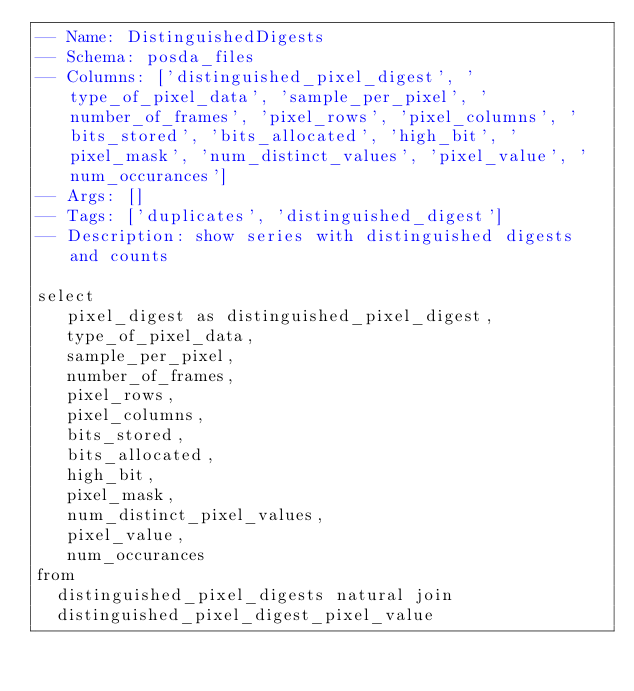<code> <loc_0><loc_0><loc_500><loc_500><_SQL_>-- Name: DistinguishedDigests
-- Schema: posda_files
-- Columns: ['distinguished_pixel_digest', 'type_of_pixel_data', 'sample_per_pixel', 'number_of_frames', 'pixel_rows', 'pixel_columns', 'bits_stored', 'bits_allocated', 'high_bit', 'pixel_mask', 'num_distinct_values', 'pixel_value', 'num_occurances']
-- Args: []
-- Tags: ['duplicates', 'distinguished_digest']
-- Description: show series with distinguished digests and counts

select
   pixel_digest as distinguished_pixel_digest,
   type_of_pixel_data,
   sample_per_pixel,
   number_of_frames,
   pixel_rows,
   pixel_columns,
   bits_stored,
   bits_allocated,
   high_bit,
   pixel_mask,
   num_distinct_pixel_values,
   pixel_value,
   num_occurances
from 
  distinguished_pixel_digests natural join
  distinguished_pixel_digest_pixel_value</code> 